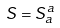<formula> <loc_0><loc_0><loc_500><loc_500>S = S _ { a } ^ { a }</formula> 